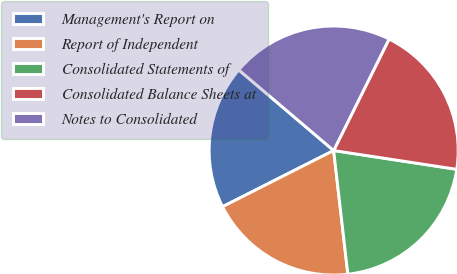Convert chart. <chart><loc_0><loc_0><loc_500><loc_500><pie_chart><fcel>Management's Report on<fcel>Report of Independent<fcel>Consolidated Statements of<fcel>Consolidated Balance Sheets at<fcel>Notes to Consolidated<nl><fcel>18.66%<fcel>19.37%<fcel>20.77%<fcel>20.07%<fcel>21.13%<nl></chart> 